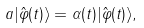Convert formula to latex. <formula><loc_0><loc_0><loc_500><loc_500>a | \hat { \varphi } ( t ) \rangle = \alpha ( t ) | \hat { \varphi } ( t ) \rangle ,</formula> 